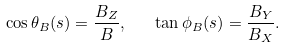<formula> <loc_0><loc_0><loc_500><loc_500>\cos \theta _ { B } ( s ) = \frac { B _ { Z } } { B } , \quad \tan \phi _ { B } ( s ) = \frac { B _ { Y } } { B _ { X } } .</formula> 